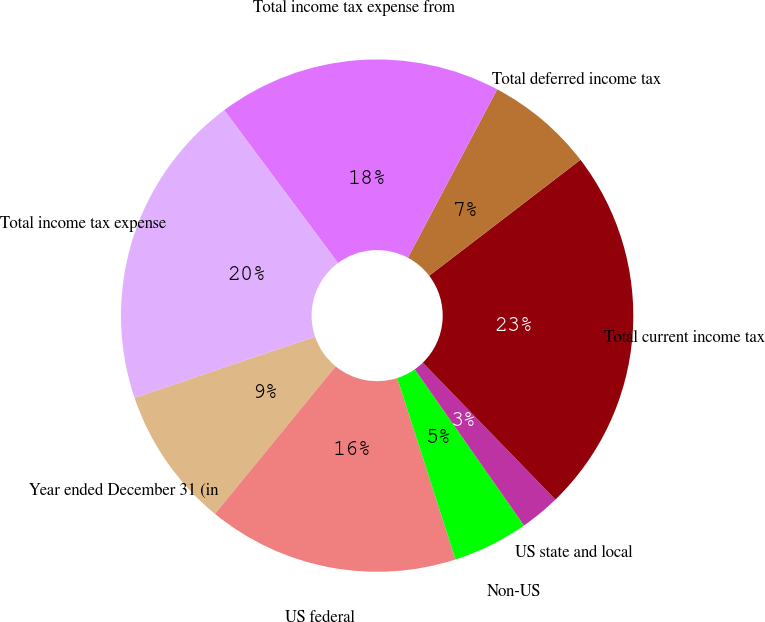Convert chart to OTSL. <chart><loc_0><loc_0><loc_500><loc_500><pie_chart><fcel>Year ended December 31 (in<fcel>US federal<fcel>Non-US<fcel>US state and local<fcel>Total current income tax<fcel>Total deferred income tax<fcel>Total income tax expense from<fcel>Total income tax expense<nl><fcel>8.89%<fcel>15.86%<fcel>4.77%<fcel>2.53%<fcel>23.16%<fcel>6.83%<fcel>17.95%<fcel>20.01%<nl></chart> 